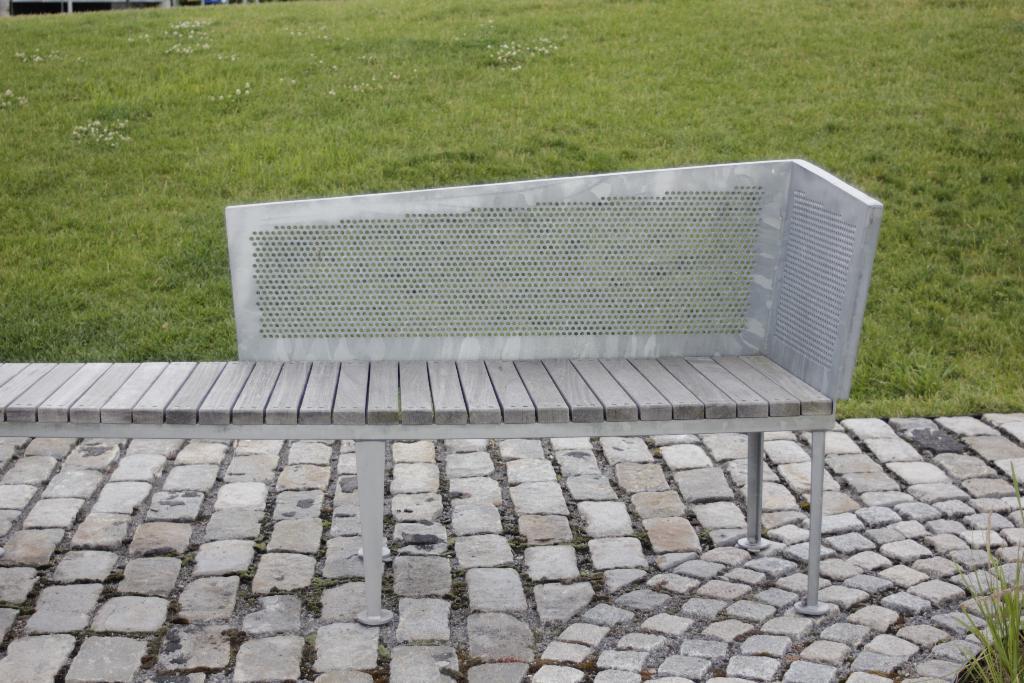How would you summarize this image in a sentence or two? In the picture we can see a stones path with a bench on it and behind it we can see a grass surface. 